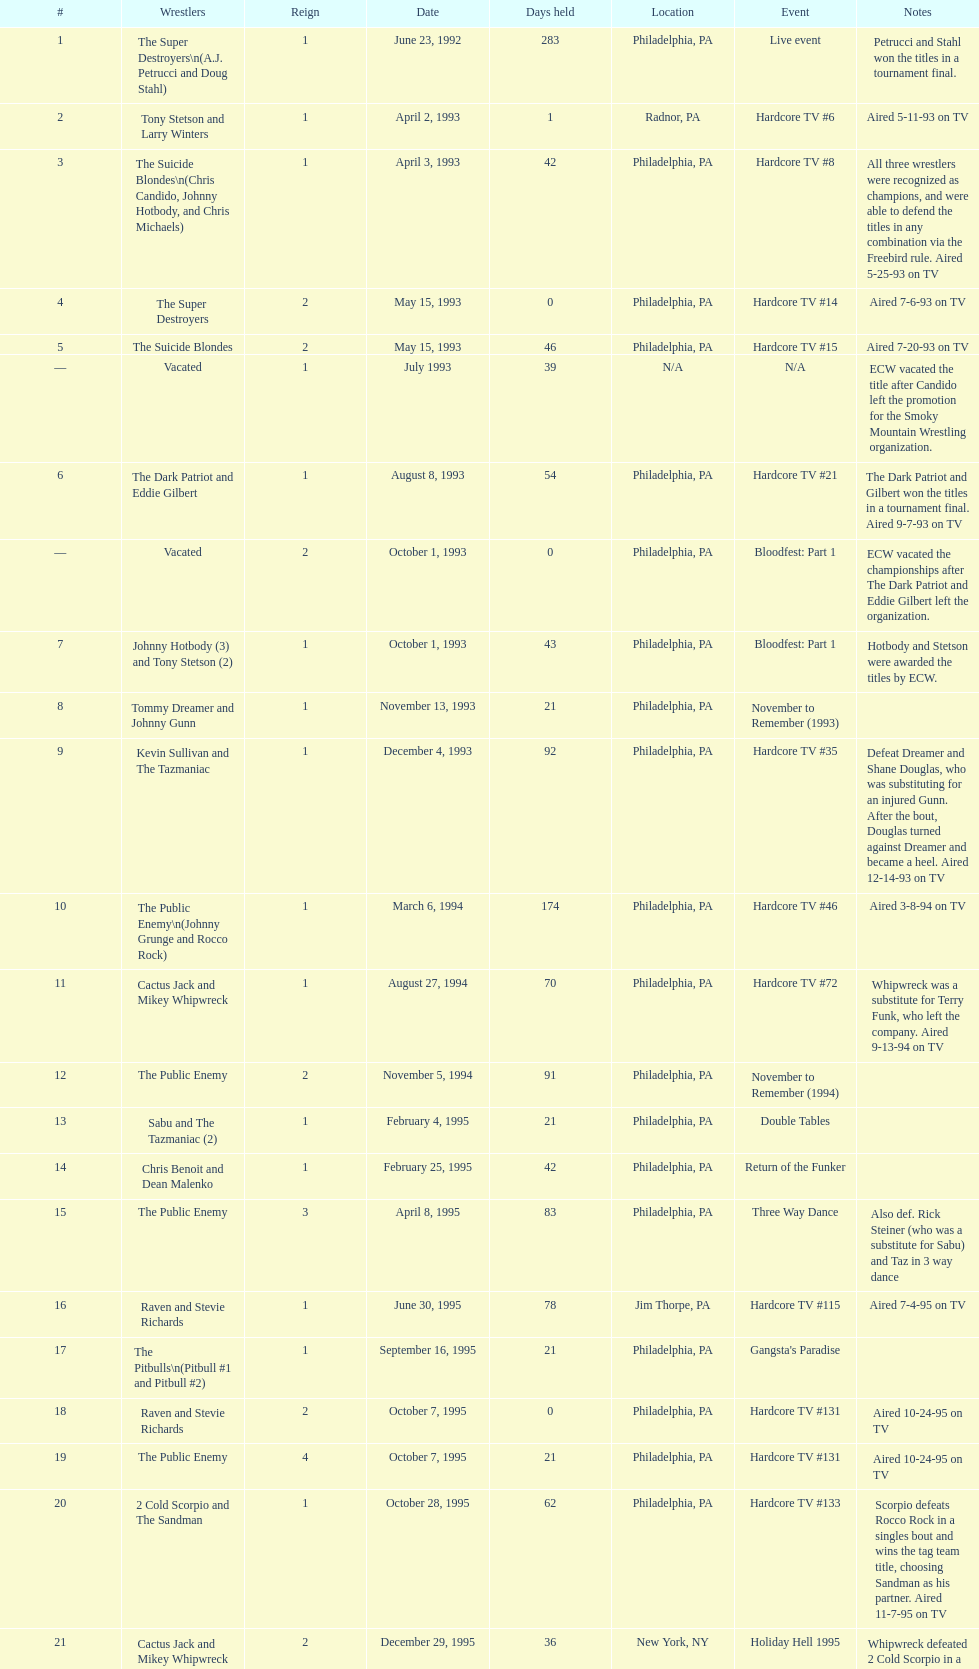Give me the full table as a dictionary. {'header': ['#', 'Wrestlers', 'Reign', 'Date', 'Days held', 'Location', 'Event', 'Notes'], 'rows': [['1', 'The Super Destroyers\\n(A.J. Petrucci and Doug Stahl)', '1', 'June 23, 1992', '283', 'Philadelphia, PA', 'Live event', 'Petrucci and Stahl won the titles in a tournament final.'], ['2', 'Tony Stetson and Larry Winters', '1', 'April 2, 1993', '1', 'Radnor, PA', 'Hardcore TV #6', 'Aired 5-11-93 on TV'], ['3', 'The Suicide Blondes\\n(Chris Candido, Johnny Hotbody, and Chris Michaels)', '1', 'April 3, 1993', '42', 'Philadelphia, PA', 'Hardcore TV #8', 'All three wrestlers were recognized as champions, and were able to defend the titles in any combination via the Freebird rule. Aired 5-25-93 on TV'], ['4', 'The Super Destroyers', '2', 'May 15, 1993', '0', 'Philadelphia, PA', 'Hardcore TV #14', 'Aired 7-6-93 on TV'], ['5', 'The Suicide Blondes', '2', 'May 15, 1993', '46', 'Philadelphia, PA', 'Hardcore TV #15', 'Aired 7-20-93 on TV'], ['—', 'Vacated', '1', 'July 1993', '39', 'N/A', 'N/A', 'ECW vacated the title after Candido left the promotion for the Smoky Mountain Wrestling organization.'], ['6', 'The Dark Patriot and Eddie Gilbert', '1', 'August 8, 1993', '54', 'Philadelphia, PA', 'Hardcore TV #21', 'The Dark Patriot and Gilbert won the titles in a tournament final. Aired 9-7-93 on TV'], ['—', 'Vacated', '2', 'October 1, 1993', '0', 'Philadelphia, PA', 'Bloodfest: Part 1', 'ECW vacated the championships after The Dark Patriot and Eddie Gilbert left the organization.'], ['7', 'Johnny Hotbody (3) and Tony Stetson (2)', '1', 'October 1, 1993', '43', 'Philadelphia, PA', 'Bloodfest: Part 1', 'Hotbody and Stetson were awarded the titles by ECW.'], ['8', 'Tommy Dreamer and Johnny Gunn', '1', 'November 13, 1993', '21', 'Philadelphia, PA', 'November to Remember (1993)', ''], ['9', 'Kevin Sullivan and The Tazmaniac', '1', 'December 4, 1993', '92', 'Philadelphia, PA', 'Hardcore TV #35', 'Defeat Dreamer and Shane Douglas, who was substituting for an injured Gunn. After the bout, Douglas turned against Dreamer and became a heel. Aired 12-14-93 on TV'], ['10', 'The Public Enemy\\n(Johnny Grunge and Rocco Rock)', '1', 'March 6, 1994', '174', 'Philadelphia, PA', 'Hardcore TV #46', 'Aired 3-8-94 on TV'], ['11', 'Cactus Jack and Mikey Whipwreck', '1', 'August 27, 1994', '70', 'Philadelphia, PA', 'Hardcore TV #72', 'Whipwreck was a substitute for Terry Funk, who left the company. Aired 9-13-94 on TV'], ['12', 'The Public Enemy', '2', 'November 5, 1994', '91', 'Philadelphia, PA', 'November to Remember (1994)', ''], ['13', 'Sabu and The Tazmaniac (2)', '1', 'February 4, 1995', '21', 'Philadelphia, PA', 'Double Tables', ''], ['14', 'Chris Benoit and Dean Malenko', '1', 'February 25, 1995', '42', 'Philadelphia, PA', 'Return of the Funker', ''], ['15', 'The Public Enemy', '3', 'April 8, 1995', '83', 'Philadelphia, PA', 'Three Way Dance', 'Also def. Rick Steiner (who was a substitute for Sabu) and Taz in 3 way dance'], ['16', 'Raven and Stevie Richards', '1', 'June 30, 1995', '78', 'Jim Thorpe, PA', 'Hardcore TV #115', 'Aired 7-4-95 on TV'], ['17', 'The Pitbulls\\n(Pitbull #1 and Pitbull #2)', '1', 'September 16, 1995', '21', 'Philadelphia, PA', "Gangsta's Paradise", ''], ['18', 'Raven and Stevie Richards', '2', 'October 7, 1995', '0', 'Philadelphia, PA', 'Hardcore TV #131', 'Aired 10-24-95 on TV'], ['19', 'The Public Enemy', '4', 'October 7, 1995', '21', 'Philadelphia, PA', 'Hardcore TV #131', 'Aired 10-24-95 on TV'], ['20', '2 Cold Scorpio and The Sandman', '1', 'October 28, 1995', '62', 'Philadelphia, PA', 'Hardcore TV #133', 'Scorpio defeats Rocco Rock in a singles bout and wins the tag team title, choosing Sandman as his partner. Aired 11-7-95 on TV'], ['21', 'Cactus Jack and Mikey Whipwreck', '2', 'December 29, 1995', '36', 'New York, NY', 'Holiday Hell 1995', "Whipwreck defeated 2 Cold Scorpio in a singles match to win both the tag team titles and the ECW World Television Championship; Cactus Jack came out and declared himself to be Mikey's partner after he won the match."], ['22', 'The Eliminators\\n(Kronus and Saturn)', '1', 'February 3, 1996', '182', 'New York, NY', 'Big Apple Blizzard Blast', ''], ['23', 'The Gangstas\\n(Mustapha Saed and New Jack)', '1', 'August 3, 1996', '139', 'Philadelphia, PA', 'Doctor Is In', ''], ['24', 'The Eliminators', '2', 'December 20, 1996', '85', 'Middletown, NY', 'Hardcore TV #193', 'Aired on 12/31/96 on Hardcore TV'], ['25', 'The Dudley Boyz\\n(Buh Buh Ray Dudley and D-Von Dudley)', '1', 'March 15, 1997', '29', 'Philadelphia, PA', 'Hostile City Showdown', 'Aired 3/20/97 on Hardcore TV'], ['26', 'The Eliminators', '3', 'April 13, 1997', '68', 'Philadelphia, PA', 'Barely Legal', ''], ['27', 'The Dudley Boyz', '2', 'June 20, 1997', '29', 'Waltham, MA', 'Hardcore TV #218', 'The Dudley Boyz defeated Kronus in a handicap match as a result of a sidelining injury sustained by Saturn. Aired 6-26-97 on TV'], ['28', 'The Gangstas', '2', 'July 19, 1997', '29', 'Philadelphia, PA', 'Heat Wave 1997/Hardcore TV #222', 'Aired 7-24-97 on TV'], ['29', 'The Dudley Boyz', '3', 'August 17, 1997', '95', 'Fort Lauderdale, FL', 'Hardcore Heaven (1997)', 'The Dudley Boyz won the championship via forfeit as a result of Mustapha Saed leaving the promotion before Hardcore Heaven took place.'], ['30', 'The Gangstanators\\n(Kronus (4) and New Jack (3))', '1', 'September 20, 1997', '28', 'Philadelphia, PA', 'As Good as it Gets', 'Aired 9-27-97 on TV'], ['31', 'Full Blooded Italians\\n(Little Guido and Tracy Smothers)', '1', 'October 18, 1997', '48', 'Philadelphia, PA', 'Hardcore TV #236', 'Aired 11-1-97 on TV'], ['32', 'Doug Furnas and Phil LaFon', '1', 'December 5, 1997', '1', 'Waltham, MA', 'Live event', ''], ['33', 'Chris Candido (3) and Lance Storm', '1', 'December 6, 1997', '203', 'Philadelphia, PA', 'Better than Ever', ''], ['34', 'Sabu (2) and Rob Van Dam', '1', 'June 27, 1998', '119', 'Philadelphia, PA', 'Hardcore TV #271', 'Aired 7-1-98 on TV'], ['35', 'The Dudley Boyz', '4', 'October 24, 1998', '8', 'Cleveland, OH', 'Hardcore TV #288', 'Aired 10-28-98 on TV'], ['36', 'Balls Mahoney and Masato Tanaka', '1', 'November 1, 1998', '5', 'New Orleans, LA', 'November to Remember (1998)', ''], ['37', 'The Dudley Boyz', '5', 'November 6, 1998', '37', 'New York, NY', 'Hardcore TV #290', 'Aired 11-11-98 on TV'], ['38', 'Sabu (3) and Rob Van Dam', '2', 'December 13, 1998', '125', 'Tokyo, Japan', 'ECW/FMW Supershow II', 'Aired 12-16-98 on TV'], ['39', 'The Dudley Boyz', '6', 'April 17, 1999', '92', 'Buffalo, NY', 'Hardcore TV #313', 'D-Von Dudley defeated Van Dam in a singles match to win the championship for his team. Aired 4-23-99 on TV'], ['40', 'Spike Dudley and Balls Mahoney (2)', '1', 'July 18, 1999', '26', 'Dayton, OH', 'Heat Wave (1999)', ''], ['41', 'The Dudley Boyz', '7', 'August 13, 1999', '1', 'Cleveland, OH', 'Hardcore TV #330', 'Aired 8-20-99 on TV'], ['42', 'Spike Dudley and Balls Mahoney (3)', '2', 'August 14, 1999', '12', 'Toledo, OH', 'Hardcore TV #331', 'Aired 8-27-99 on TV'], ['43', 'The Dudley Boyz', '8', 'August 26, 1999', '0', 'New York, NY', 'ECW on TNN#2', 'Aired 9-3-99 on TV'], ['44', 'Tommy Dreamer (2) and Raven (3)', '1', 'August 26, 1999', '136', 'New York, NY', 'ECW on TNN#2', 'Aired 9-3-99 on TV'], ['45', 'Impact Players\\n(Justin Credible and Lance Storm (2))', '1', 'January 9, 2000', '48', 'Birmingham, AL', 'Guilty as Charged (2000)', ''], ['46', 'Tommy Dreamer (3) and Masato Tanaka (2)', '1', 'February 26, 2000', '7', 'Cincinnati, OH', 'Hardcore TV #358', 'Aired 3-7-00 on TV'], ['47', 'Mike Awesome and Raven (4)', '1', 'March 4, 2000', '8', 'Philadelphia, PA', 'ECW on TNN#29', 'Aired 3-10-00 on TV'], ['48', 'Impact Players\\n(Justin Credible and Lance Storm (3))', '2', 'March 12, 2000', '31', 'Danbury, CT', 'Living Dangerously', ''], ['—', 'Vacated', '3', 'April 22, 2000', '125', 'Philadelphia, PA', 'Live event', 'At CyberSlam, Justin Credible threw down the titles to become eligible for the ECW World Heavyweight Championship. Storm later left for World Championship Wrestling. As a result of the circumstances, Credible vacated the championship.'], ['49', 'Yoshihiro Tajiri and Mikey Whipwreck (3)', '1', 'August 25, 2000', '1', 'New York, NY', 'ECW on TNN#55', 'Aired 9-1-00 on TV'], ['50', 'Full Blooded Italians\\n(Little Guido (2) and Tony Mamaluke)', '1', 'August 26, 2000', '99', 'New York, NY', 'ECW on TNN#56', 'Aired 9-8-00 on TV'], ['51', 'Danny Doring and Roadkill', '1', 'December 3, 2000', '122', 'New York, NY', 'Massacre on 34th Street', "Doring and Roadkill's reign was the final one in the title's history."]]} How many times, between june 23, 1992 and december 3, 2000, did the suicide blondes maintain the championship? 2. 